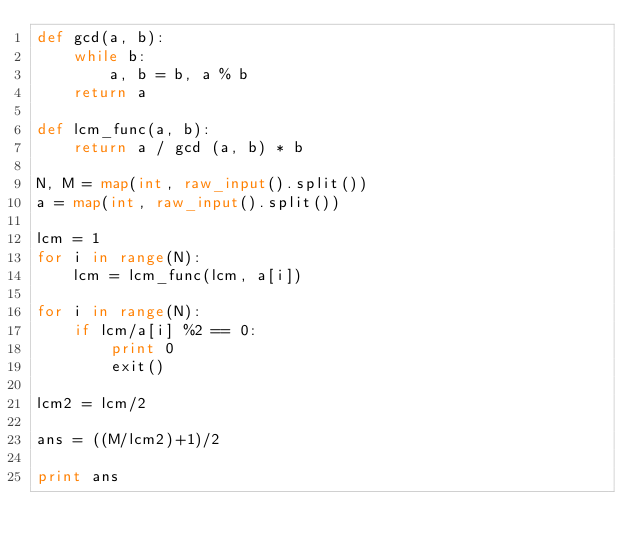<code> <loc_0><loc_0><loc_500><loc_500><_Python_>def gcd(a, b):
    while b:
        a, b = b, a % b
    return a

def lcm_func(a, b):
    return a / gcd (a, b) * b

N, M = map(int, raw_input().split())
a = map(int, raw_input().split())

lcm = 1
for i in range(N):
    lcm = lcm_func(lcm, a[i])

for i in range(N):
    if lcm/a[i] %2 == 0:
        print 0
        exit()

lcm2 = lcm/2

ans = ((M/lcm2)+1)/2

print ans
</code> 